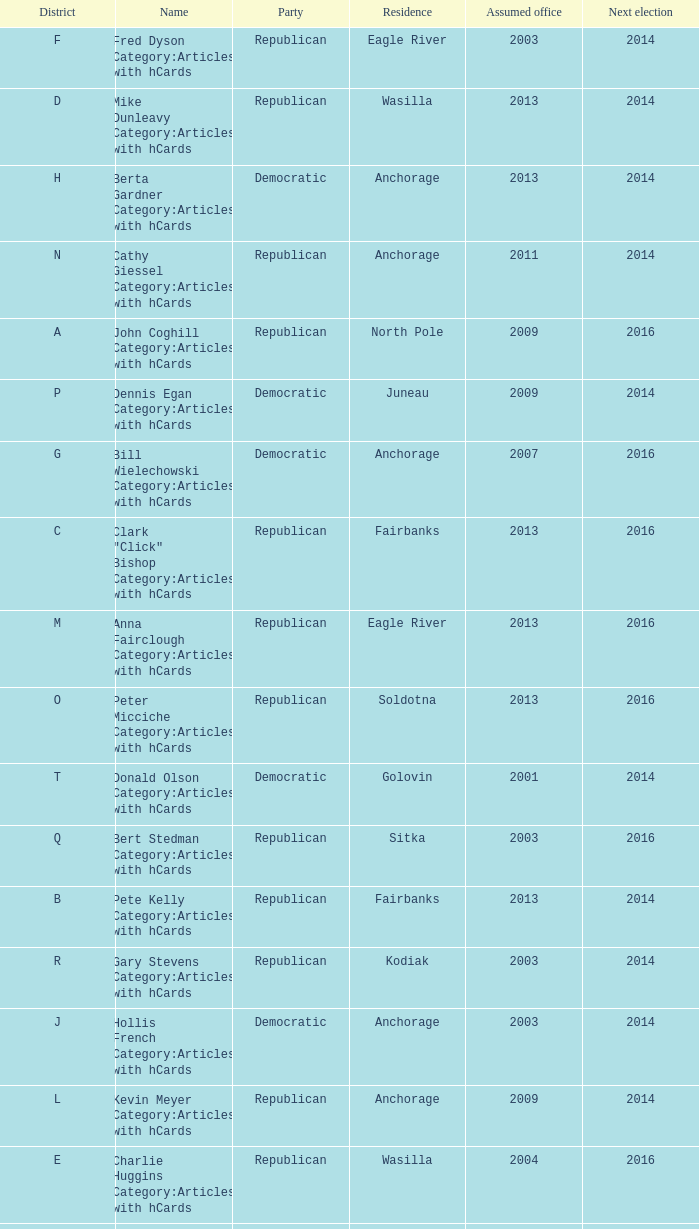What is the party of the Senator in District A, who assumed office before 2013 and will be up for re-election after 2014? Republican. Write the full table. {'header': ['District', 'Name', 'Party', 'Residence', 'Assumed office', 'Next election'], 'rows': [['F', 'Fred Dyson Category:Articles with hCards', 'Republican', 'Eagle River', '2003', '2014'], ['D', 'Mike Dunleavy Category:Articles with hCards', 'Republican', 'Wasilla', '2013', '2014'], ['H', 'Berta Gardner Category:Articles with hCards', 'Democratic', 'Anchorage', '2013', '2014'], ['N', 'Cathy Giessel Category:Articles with hCards', 'Republican', 'Anchorage', '2011', '2014'], ['A', 'John Coghill Category:Articles with hCards', 'Republican', 'North Pole', '2009', '2016'], ['P', 'Dennis Egan Category:Articles with hCards', 'Democratic', 'Juneau', '2009', '2014'], ['G', 'Bill Wielechowski Category:Articles with hCards', 'Democratic', 'Anchorage', '2007', '2016'], ['C', 'Clark "Click" Bishop Category:Articles with hCards', 'Republican', 'Fairbanks', '2013', '2016'], ['M', 'Anna Fairclough Category:Articles with hCards', 'Republican', 'Eagle River', '2013', '2016'], ['O', 'Peter Micciche Category:Articles with hCards', 'Republican', 'Soldotna', '2013', '2016'], ['T', 'Donald Olson Category:Articles with hCards', 'Democratic', 'Golovin', '2001', '2014'], ['Q', 'Bert Stedman Category:Articles with hCards', 'Republican', 'Sitka', '2003', '2016'], ['B', 'Pete Kelly Category:Articles with hCards', 'Republican', 'Fairbanks', '2013', '2014'], ['R', 'Gary Stevens Category:Articles with hCards', 'Republican', 'Kodiak', '2003', '2014'], ['J', 'Hollis French Category:Articles with hCards', 'Democratic', 'Anchorage', '2003', '2014'], ['L', 'Kevin Meyer Category:Articles with hCards', 'Republican', 'Anchorage', '2009', '2014'], ['E', 'Charlie Huggins Category:Articles with hCards', 'Republican', 'Wasilla', '2004', '2016'], ['S', 'Lyman Hoffman Category:Articles with hCards', 'Democratic', 'Bethel', '1995', '2016'], ['K', 'Lesil McGuire Category:Articles with hCards', 'Republican', 'Anchorage', '2007', '2016'], ['I', 'Johnny Ellis Category:Articles with hCards', 'Democratic', 'Anchorage', '1993', '2016']]} 